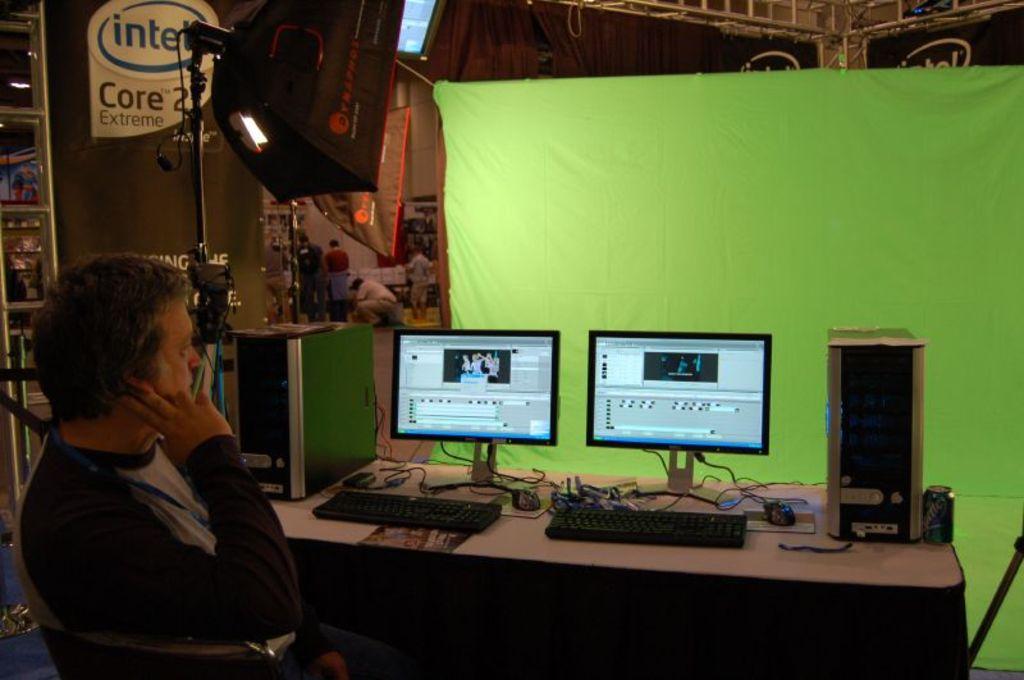Is that person watching a movie or working?
Provide a succinct answer. Answering does not require reading text in the image. Which processor brand is featured on the top left?
Ensure brevity in your answer.  Intel. 